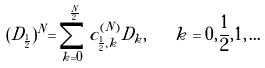Convert formula to latex. <formula><loc_0><loc_0><loc_500><loc_500>( D _ { \frac { 1 } { 2 } } ) ^ { N } = \sum _ { k = 0 } ^ { \frac { N } { 2 } } c _ { { \frac { 1 } { 2 } } , k } ^ { ( N ) } D _ { k } , \quad k = 0 , \frac { 1 } { 2 } , 1 , \dots</formula> 